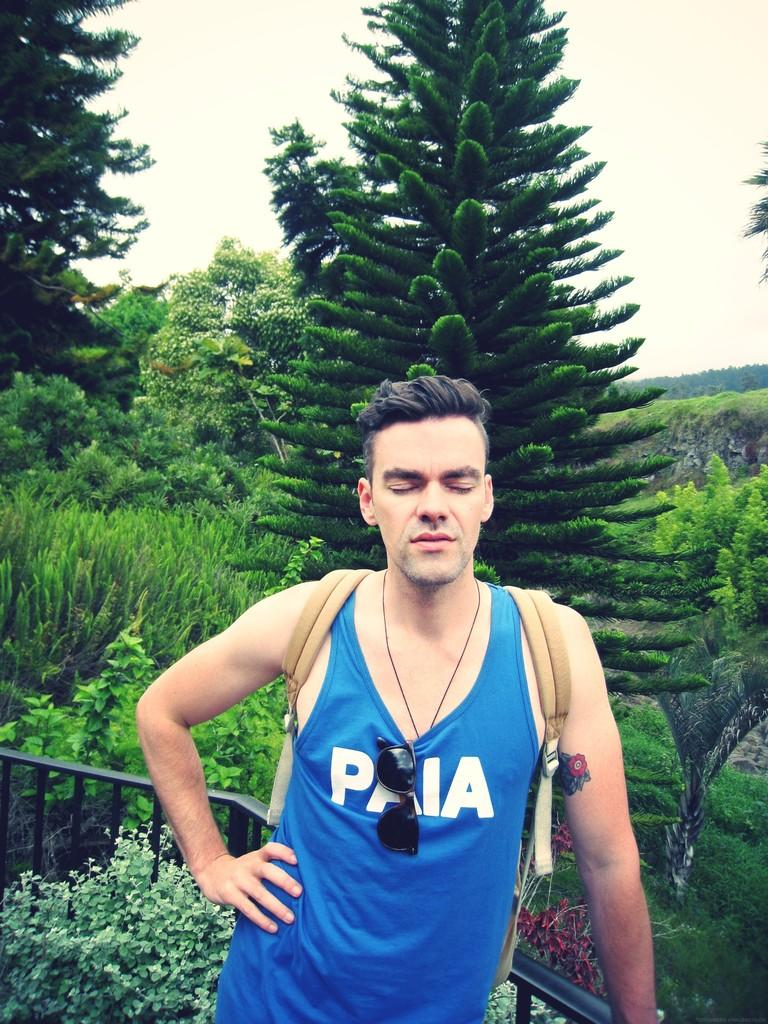<image>
Write a terse but informative summary of the picture. a man with closed eyes and PAIA tank top in front of green trees 